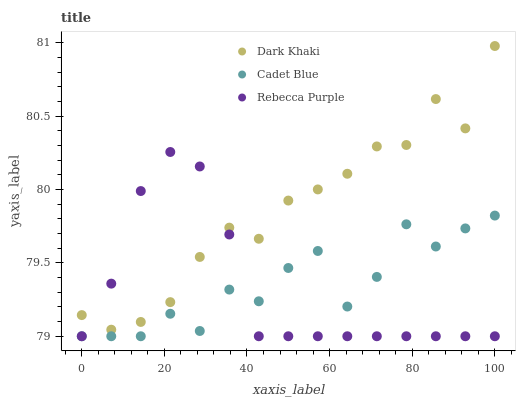Does Rebecca Purple have the minimum area under the curve?
Answer yes or no. Yes. Does Dark Khaki have the maximum area under the curve?
Answer yes or no. Yes. Does Cadet Blue have the minimum area under the curve?
Answer yes or no. No. Does Cadet Blue have the maximum area under the curve?
Answer yes or no. No. Is Rebecca Purple the smoothest?
Answer yes or no. Yes. Is Cadet Blue the roughest?
Answer yes or no. Yes. Is Cadet Blue the smoothest?
Answer yes or no. No. Is Rebecca Purple the roughest?
Answer yes or no. No. Does Cadet Blue have the lowest value?
Answer yes or no. Yes. Does Dark Khaki have the highest value?
Answer yes or no. Yes. Does Rebecca Purple have the highest value?
Answer yes or no. No. Is Cadet Blue less than Dark Khaki?
Answer yes or no. Yes. Is Dark Khaki greater than Cadet Blue?
Answer yes or no. Yes. Does Dark Khaki intersect Rebecca Purple?
Answer yes or no. Yes. Is Dark Khaki less than Rebecca Purple?
Answer yes or no. No. Is Dark Khaki greater than Rebecca Purple?
Answer yes or no. No. Does Cadet Blue intersect Dark Khaki?
Answer yes or no. No. 